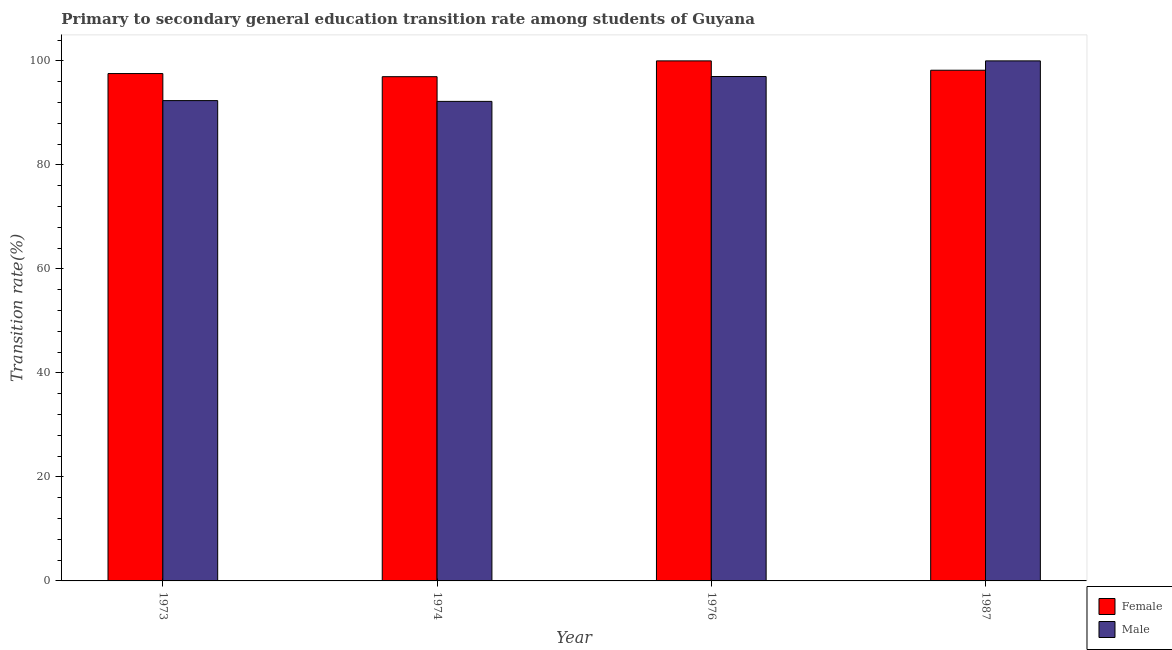How many different coloured bars are there?
Keep it short and to the point. 2. Are the number of bars on each tick of the X-axis equal?
Provide a succinct answer. Yes. How many bars are there on the 4th tick from the left?
Ensure brevity in your answer.  2. How many bars are there on the 4th tick from the right?
Offer a very short reply. 2. What is the label of the 2nd group of bars from the left?
Offer a very short reply. 1974. In how many cases, is the number of bars for a given year not equal to the number of legend labels?
Offer a terse response. 0. What is the transition rate among male students in 1973?
Ensure brevity in your answer.  92.36. Across all years, what is the minimum transition rate among male students?
Provide a short and direct response. 92.21. In which year was the transition rate among female students maximum?
Offer a very short reply. 1976. In which year was the transition rate among male students minimum?
Keep it short and to the point. 1974. What is the total transition rate among male students in the graph?
Your answer should be compact. 381.57. What is the difference between the transition rate among female students in 1976 and that in 1987?
Provide a short and direct response. 1.8. What is the difference between the transition rate among male students in 1973 and the transition rate among female students in 1974?
Your answer should be compact. 0.15. What is the average transition rate among female students per year?
Offer a terse response. 98.18. In the year 1976, what is the difference between the transition rate among female students and transition rate among male students?
Provide a succinct answer. 0. What is the ratio of the transition rate among male students in 1974 to that in 1976?
Keep it short and to the point. 0.95. Is the transition rate among male students in 1974 less than that in 1976?
Your response must be concise. Yes. What is the difference between the highest and the second highest transition rate among female students?
Offer a terse response. 1.8. What is the difference between the highest and the lowest transition rate among male students?
Give a very brief answer. 7.79. In how many years, is the transition rate among male students greater than the average transition rate among male students taken over all years?
Keep it short and to the point. 2. Is the sum of the transition rate among female students in 1976 and 1987 greater than the maximum transition rate among male students across all years?
Ensure brevity in your answer.  Yes. What does the 2nd bar from the left in 1987 represents?
Provide a succinct answer. Male. Are all the bars in the graph horizontal?
Offer a very short reply. No. How many years are there in the graph?
Provide a succinct answer. 4. How many legend labels are there?
Provide a succinct answer. 2. How are the legend labels stacked?
Your response must be concise. Vertical. What is the title of the graph?
Provide a succinct answer. Primary to secondary general education transition rate among students of Guyana. What is the label or title of the X-axis?
Ensure brevity in your answer.  Year. What is the label or title of the Y-axis?
Give a very brief answer. Transition rate(%). What is the Transition rate(%) of Female in 1973?
Offer a very short reply. 97.56. What is the Transition rate(%) of Male in 1973?
Your response must be concise. 92.36. What is the Transition rate(%) of Female in 1974?
Your answer should be very brief. 96.96. What is the Transition rate(%) of Male in 1974?
Ensure brevity in your answer.  92.21. What is the Transition rate(%) of Female in 1976?
Your answer should be very brief. 100. What is the Transition rate(%) of Male in 1976?
Give a very brief answer. 96.99. What is the Transition rate(%) in Female in 1987?
Provide a short and direct response. 98.2. Across all years, what is the minimum Transition rate(%) in Female?
Give a very brief answer. 96.96. Across all years, what is the minimum Transition rate(%) of Male?
Give a very brief answer. 92.21. What is the total Transition rate(%) of Female in the graph?
Provide a short and direct response. 392.73. What is the total Transition rate(%) in Male in the graph?
Give a very brief answer. 381.57. What is the difference between the Transition rate(%) of Female in 1973 and that in 1974?
Provide a short and direct response. 0.6. What is the difference between the Transition rate(%) of Male in 1973 and that in 1974?
Your response must be concise. 0.15. What is the difference between the Transition rate(%) of Female in 1973 and that in 1976?
Your answer should be compact. -2.44. What is the difference between the Transition rate(%) in Male in 1973 and that in 1976?
Keep it short and to the point. -4.63. What is the difference between the Transition rate(%) in Female in 1973 and that in 1987?
Keep it short and to the point. -0.64. What is the difference between the Transition rate(%) of Male in 1973 and that in 1987?
Offer a terse response. -7.64. What is the difference between the Transition rate(%) in Female in 1974 and that in 1976?
Your answer should be compact. -3.04. What is the difference between the Transition rate(%) in Male in 1974 and that in 1976?
Offer a very short reply. -4.78. What is the difference between the Transition rate(%) in Female in 1974 and that in 1987?
Make the answer very short. -1.24. What is the difference between the Transition rate(%) in Male in 1974 and that in 1987?
Your response must be concise. -7.79. What is the difference between the Transition rate(%) of Female in 1976 and that in 1987?
Keep it short and to the point. 1.8. What is the difference between the Transition rate(%) in Male in 1976 and that in 1987?
Ensure brevity in your answer.  -3.01. What is the difference between the Transition rate(%) of Female in 1973 and the Transition rate(%) of Male in 1974?
Your response must be concise. 5.35. What is the difference between the Transition rate(%) in Female in 1973 and the Transition rate(%) in Male in 1976?
Your response must be concise. 0.57. What is the difference between the Transition rate(%) in Female in 1973 and the Transition rate(%) in Male in 1987?
Your answer should be compact. -2.44. What is the difference between the Transition rate(%) in Female in 1974 and the Transition rate(%) in Male in 1976?
Make the answer very short. -0.03. What is the difference between the Transition rate(%) in Female in 1974 and the Transition rate(%) in Male in 1987?
Give a very brief answer. -3.04. What is the average Transition rate(%) of Female per year?
Your answer should be compact. 98.18. What is the average Transition rate(%) in Male per year?
Ensure brevity in your answer.  95.39. In the year 1973, what is the difference between the Transition rate(%) in Female and Transition rate(%) in Male?
Offer a very short reply. 5.2. In the year 1974, what is the difference between the Transition rate(%) in Female and Transition rate(%) in Male?
Offer a terse response. 4.75. In the year 1976, what is the difference between the Transition rate(%) in Female and Transition rate(%) in Male?
Give a very brief answer. 3.01. In the year 1987, what is the difference between the Transition rate(%) of Female and Transition rate(%) of Male?
Provide a short and direct response. -1.8. What is the ratio of the Transition rate(%) of Male in 1973 to that in 1974?
Offer a terse response. 1. What is the ratio of the Transition rate(%) of Female in 1973 to that in 1976?
Your answer should be compact. 0.98. What is the ratio of the Transition rate(%) in Male in 1973 to that in 1976?
Provide a succinct answer. 0.95. What is the ratio of the Transition rate(%) of Male in 1973 to that in 1987?
Give a very brief answer. 0.92. What is the ratio of the Transition rate(%) of Female in 1974 to that in 1976?
Ensure brevity in your answer.  0.97. What is the ratio of the Transition rate(%) in Male in 1974 to that in 1976?
Provide a short and direct response. 0.95. What is the ratio of the Transition rate(%) of Female in 1974 to that in 1987?
Provide a succinct answer. 0.99. What is the ratio of the Transition rate(%) in Male in 1974 to that in 1987?
Your answer should be compact. 0.92. What is the ratio of the Transition rate(%) of Female in 1976 to that in 1987?
Offer a very short reply. 1.02. What is the ratio of the Transition rate(%) of Male in 1976 to that in 1987?
Provide a short and direct response. 0.97. What is the difference between the highest and the second highest Transition rate(%) in Female?
Your answer should be very brief. 1.8. What is the difference between the highest and the second highest Transition rate(%) in Male?
Give a very brief answer. 3.01. What is the difference between the highest and the lowest Transition rate(%) of Female?
Your answer should be very brief. 3.04. What is the difference between the highest and the lowest Transition rate(%) of Male?
Ensure brevity in your answer.  7.79. 